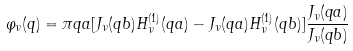<formula> <loc_0><loc_0><loc_500><loc_500>\varphi _ { \nu } ( q ) = \pi q a [ J _ { \nu } ( q b ) H ^ { ( 1 ) } _ { \nu } ( q a ) - J _ { \nu } ( q a ) H ^ { ( 1 ) } _ { \nu } ( q b ) ] \frac { J _ { \nu } ( q a ) } { J _ { \nu } ( q b ) }</formula> 